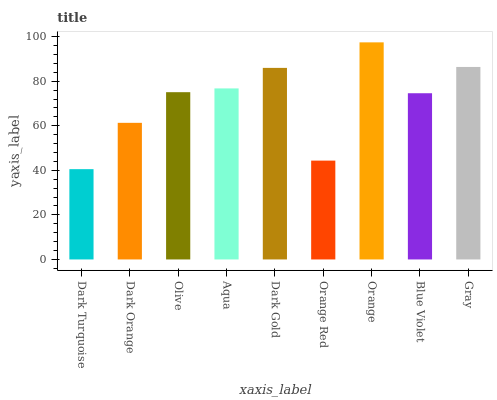Is Dark Turquoise the minimum?
Answer yes or no. Yes. Is Orange the maximum?
Answer yes or no. Yes. Is Dark Orange the minimum?
Answer yes or no. No. Is Dark Orange the maximum?
Answer yes or no. No. Is Dark Orange greater than Dark Turquoise?
Answer yes or no. Yes. Is Dark Turquoise less than Dark Orange?
Answer yes or no. Yes. Is Dark Turquoise greater than Dark Orange?
Answer yes or no. No. Is Dark Orange less than Dark Turquoise?
Answer yes or no. No. Is Olive the high median?
Answer yes or no. Yes. Is Olive the low median?
Answer yes or no. Yes. Is Orange Red the high median?
Answer yes or no. No. Is Orange Red the low median?
Answer yes or no. No. 